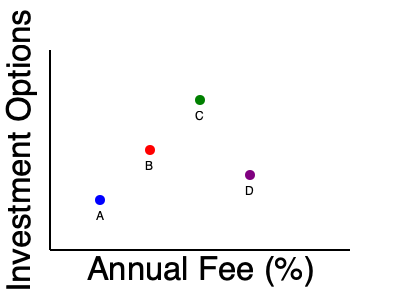Looking at the scatter plot comparing 529 plan providers, which provider seems to offer the best combination of low fees and a high number of investment options? To determine the best combination of low fees and high investment options, we need to analyze the position of each point on the graph:

1. The x-axis represents the annual fee percentage, with lower fees being more desirable (left side of the graph).
2. The y-axis represents the number of investment options, with more options being better (higher on the graph).
3. Provider A (blue): Has low fees but also fewer investment options.
4. Provider B (red): Has moderate fees and a moderate number of investment options.
5. Provider C (green): Has slightly higher fees than B but offers the most investment options.
6. Provider D (purple): Has the highest fees and fewer investment options than B and C.

The ideal provider would be positioned in the upper-left corner of the graph, representing low fees and many investment options. Provider C (green) is closest to this ideal position, offering the most investment options while maintaining relatively competitive fees.
Answer: Provider C (green) 